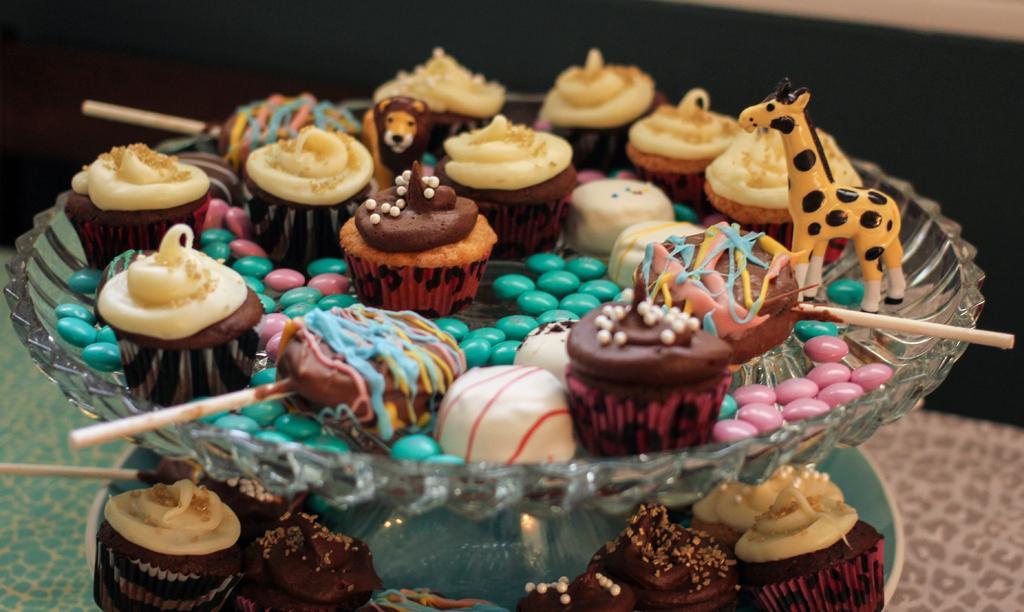Describe this image in one or two sentences. In this there are cupcakes, gems, lollipops in a bowl and this bowl is placed on the table. 